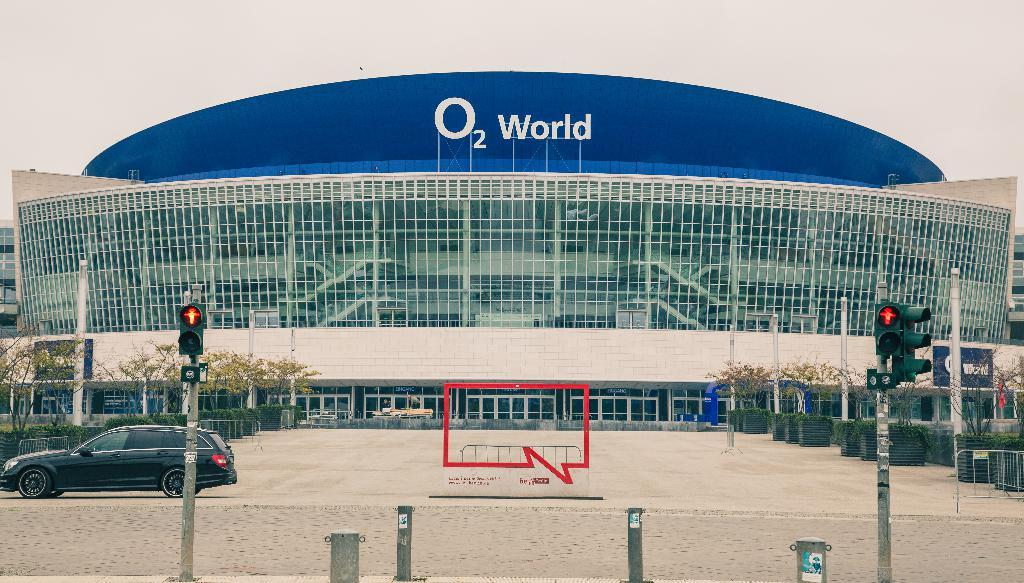What type of structure can be seen in the image? There is a building in the image. What is happening on the road in the image? Motor vehicles are present on the road. What type of barrier can be seen in the image? There are fences in the image. What type of vegetation is visible in the image? Bushes and trees are present in the image. What type of vertical structures can be seen in the image? Traffic poles are in the image. What type of traffic control devices are visible in the image? Traffic signals are visible in the image. What signage is present in the image? A name board is present in the image. What part of the natural environment is visible in the image? The sky is visible in the image. What type of rhythm can be heard coming from the building in the image? There is no indication of any rhythm or sound in the image, as it is a still photograph. What type of fire can be seen in the image? There is no fire present in the image. 